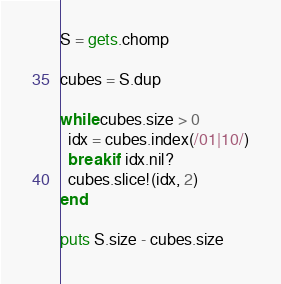<code> <loc_0><loc_0><loc_500><loc_500><_Ruby_>S = gets.chomp

cubes = S.dup

while cubes.size > 0
  idx = cubes.index(/01|10/)
  break if idx.nil?
  cubes.slice!(idx, 2)
end

puts S.size - cubes.size</code> 